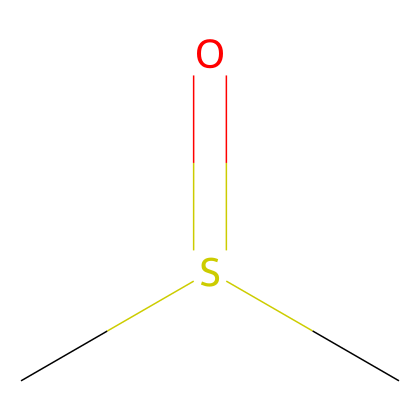What is the molecular formula of dimethyl sulfoxide? The chemical is represented by the SMILES notation, which includes two carbon atoms (C), one sulfur atom (S), and one oxygen atom (O), leading to the molecular formula of C2H6OS.
Answer: C2H6OS How many carbon atoms are in the molecule? By analyzing the SMILES code, "CS(=O)C", we identify two carbon atoms (the 'C' characters in the notation).
Answer: 2 What type of bonding is present in dimethyl sulfoxide? The structure indicates covalent bonding since the atoms are sharing electrons, as seen in the carbon-sulfur and sulfur-oxygen connections in the chemical notation.
Answer: covalent How many hydrogen atoms are attached to the carbon atoms? From the SMILES representation, each carbon in the molecule is bonded to three and two hydrogen atoms respectively, totaling five hydrogen atoms.
Answer: 6 What functional group is present in dimethyl sulfoxide? The SO group (the sulfoxide functional group) is indicated by the presence of sulfur bonded to oxygen (the "=O" represents a double bond) in the structure of the compound.
Answer: sulfoxide Is dimethyl sulfoxide a polar molecule? The presence of the sulfur and oxygen atoms, which have a significant electronegativity difference compared to carbon and hydrogen, suggests that the molecule has polar characteristics due to an unequal distribution of electron density.
Answer: yes What physical state is dimethyl sulfoxide typically found in at room temperature? Dimethyl sulfoxide is known to be a liquid at room temperature due to its molecular structure and weak intermolecular forces compared to solids and gases.
Answer: liquid 